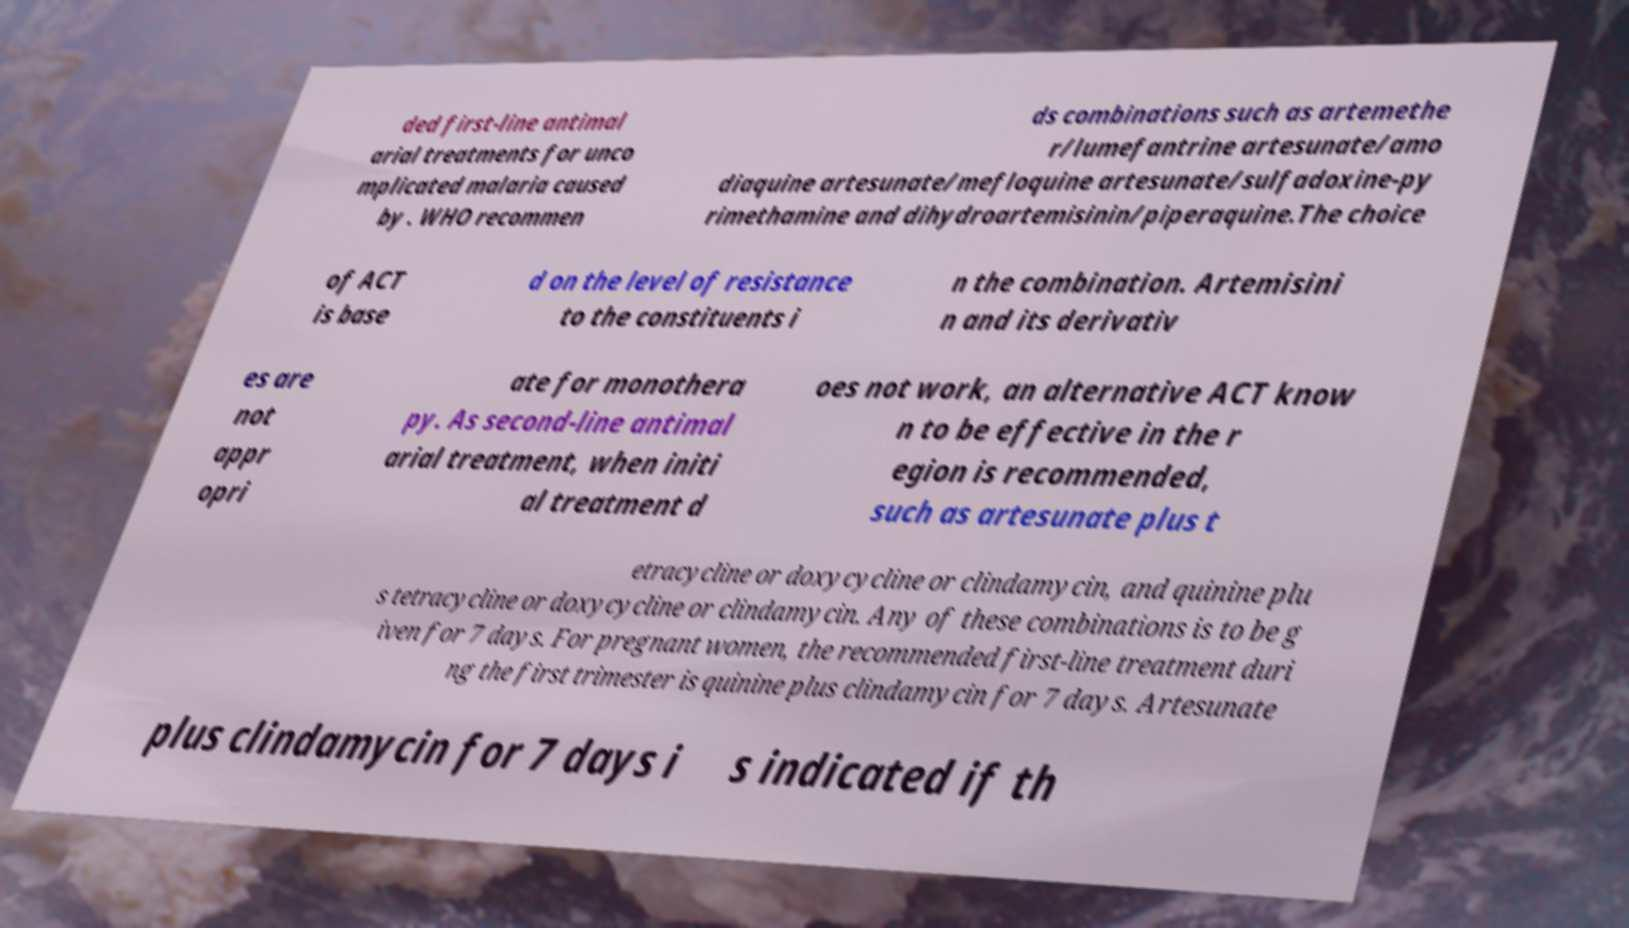Please read and relay the text visible in this image. What does it say? ded first-line antimal arial treatments for unco mplicated malaria caused by . WHO recommen ds combinations such as artemethe r/lumefantrine artesunate/amo diaquine artesunate/mefloquine artesunate/sulfadoxine-py rimethamine and dihydroartemisinin/piperaquine.The choice of ACT is base d on the level of resistance to the constituents i n the combination. Artemisini n and its derivativ es are not appr opri ate for monothera py. As second-line antimal arial treatment, when initi al treatment d oes not work, an alternative ACT know n to be effective in the r egion is recommended, such as artesunate plus t etracycline or doxycycline or clindamycin, and quinine plu s tetracycline or doxycycline or clindamycin. Any of these combinations is to be g iven for 7 days. For pregnant women, the recommended first-line treatment duri ng the first trimester is quinine plus clindamycin for 7 days. Artesunate plus clindamycin for 7 days i s indicated if th 